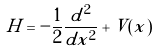Convert formula to latex. <formula><loc_0><loc_0><loc_500><loc_500>H = - \frac { 1 } { 2 } \frac { d ^ { 2 } } { d x ^ { 2 } } + V ( x )</formula> 